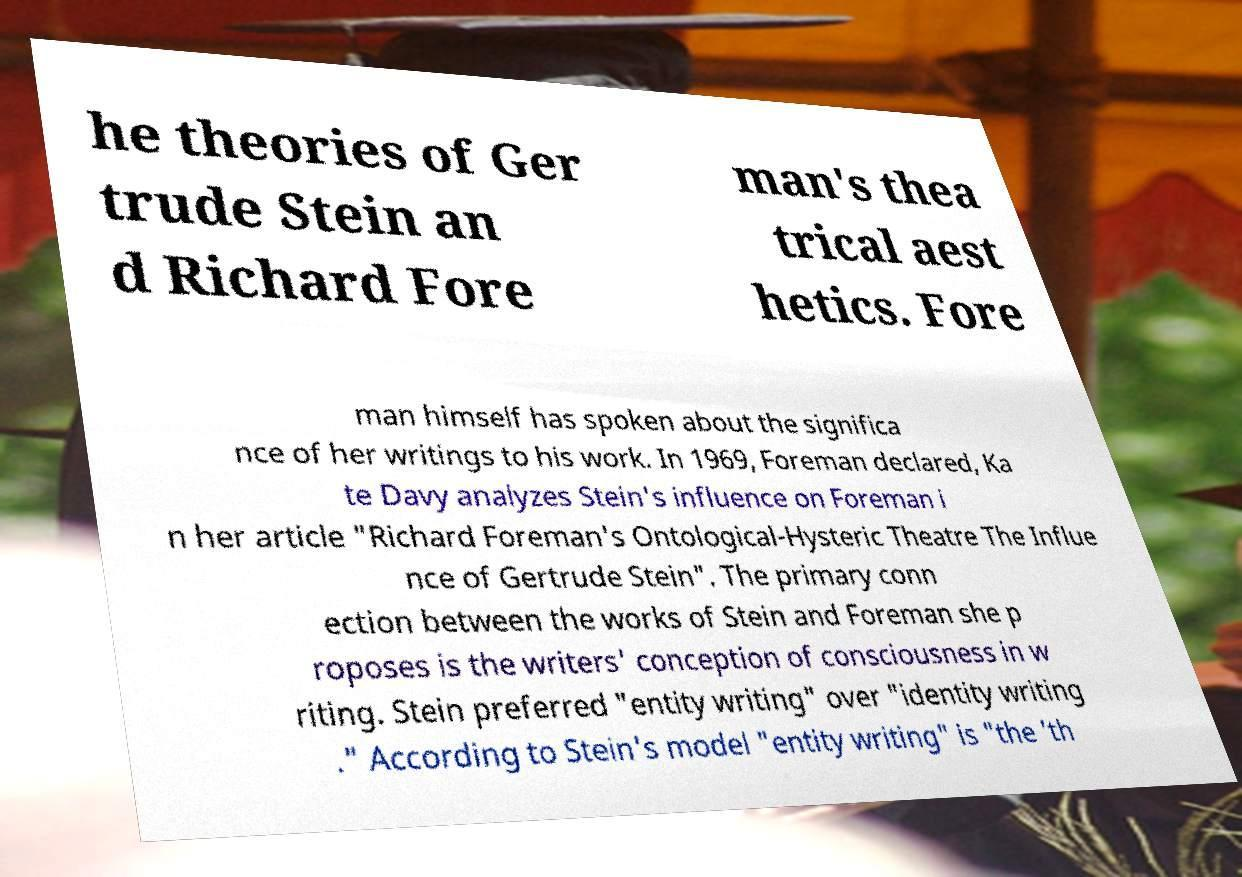Could you extract and type out the text from this image? he theories of Ger trude Stein an d Richard Fore man's thea trical aest hetics. Fore man himself has spoken about the significa nce of her writings to his work. In 1969, Foreman declared, Ka te Davy analyzes Stein's influence on Foreman i n her article "Richard Foreman's Ontological-Hysteric Theatre The Influe nce of Gertrude Stein". The primary conn ection between the works of Stein and Foreman she p roposes is the writers' conception of consciousness in w riting. Stein preferred "entity writing" over "identity writing ." According to Stein's model "entity writing" is "the 'th 